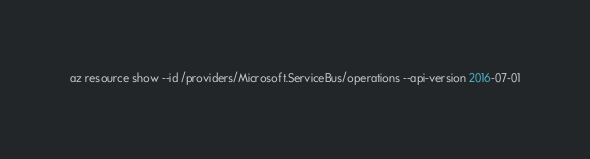<code> <loc_0><loc_0><loc_500><loc_500><_Bash_>
az resource show --id /providers/Microsoft.ServiceBus/operations --api-version 2016-07-01</code> 